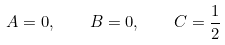<formula> <loc_0><loc_0><loc_500><loc_500>A = 0 , \quad B = 0 , \quad C = \frac { 1 } { 2 }</formula> 